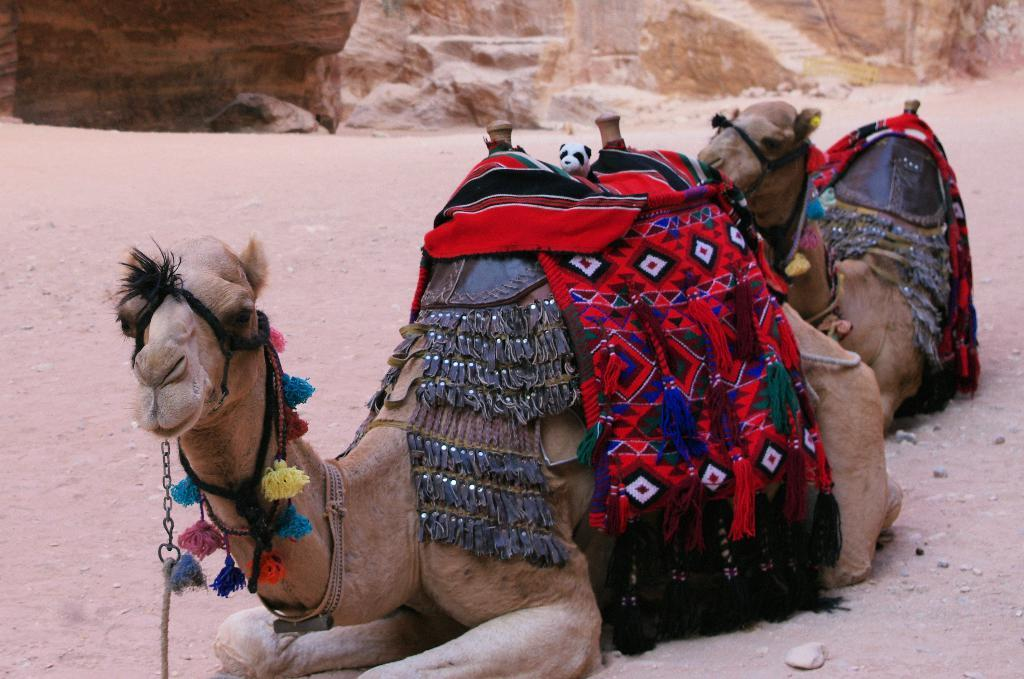How many camels are in the image? There are two camels in the image. What are the camels doing in the image? The camels are laying on the land. What is on the camels' backs? There are colorful cloths on the camels' backs. What can be seen in the background of the image? There are sand hills in the background of the image. What type of wave can be seen crashing on the shore in the image? There is no shore or wave present in the image; it features two camels laying on the land with sand hills in the background. 